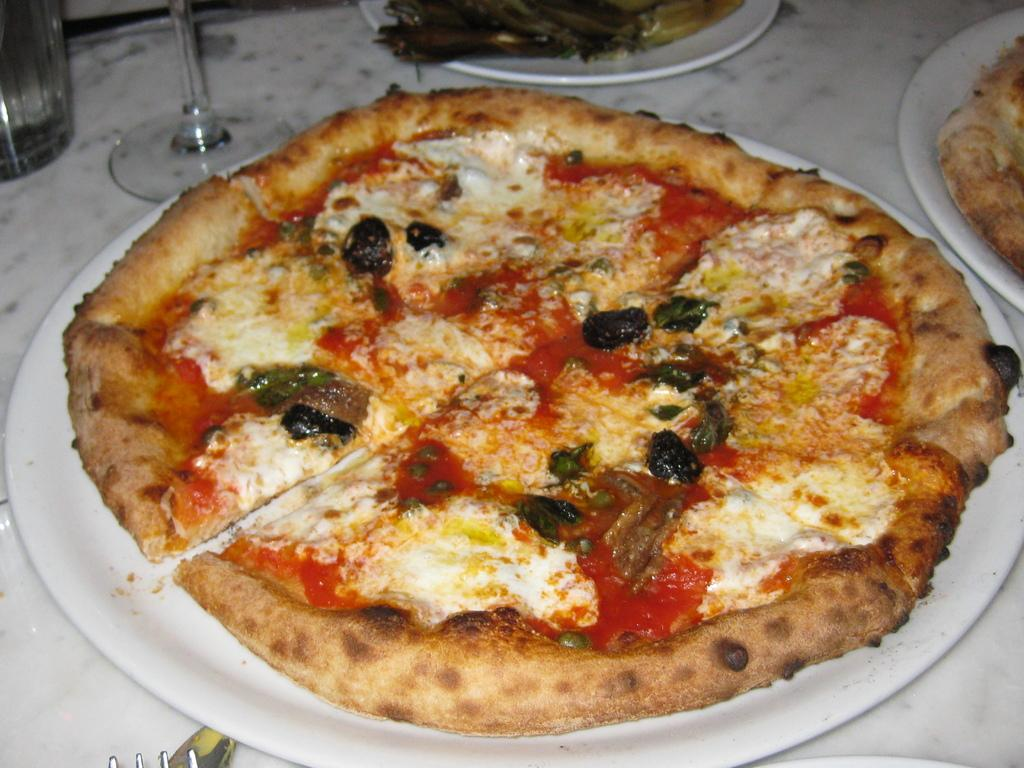What type of objects can be seen with food in the image? There are plates with food in the image. What other objects are visible in the image? There are glasses visible in the image. What is the color of the surface the objects are placed on? The surface the objects are placed on appears to be white in color. What might the white surface be used for? The white surface resembles a table, which is typically used for placing and serving food and drinks. What is the tax rate on the leather goods in the image? There are no leather goods or tax rates mentioned in the image; it only shows plates with food and glasses. 